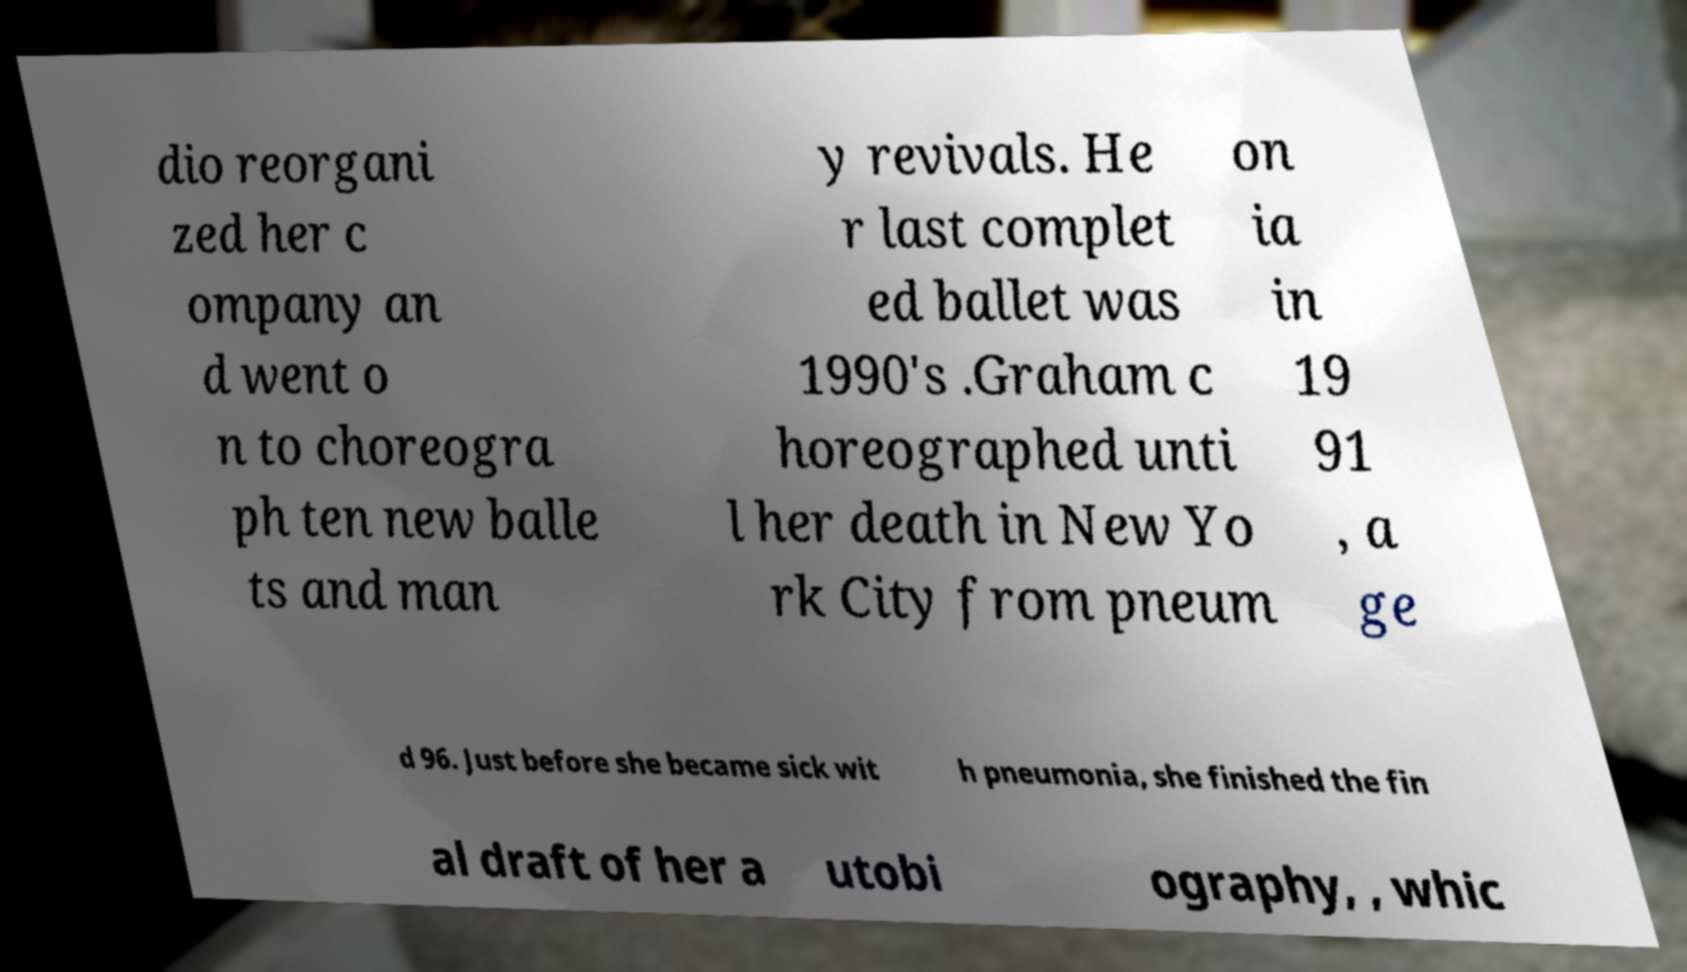Please read and relay the text visible in this image. What does it say? dio reorgani zed her c ompany an d went o n to choreogra ph ten new balle ts and man y revivals. He r last complet ed ballet was 1990's .Graham c horeographed unti l her death in New Yo rk City from pneum on ia in 19 91 , a ge d 96. Just before she became sick wit h pneumonia, she finished the fin al draft of her a utobi ography, , whic 